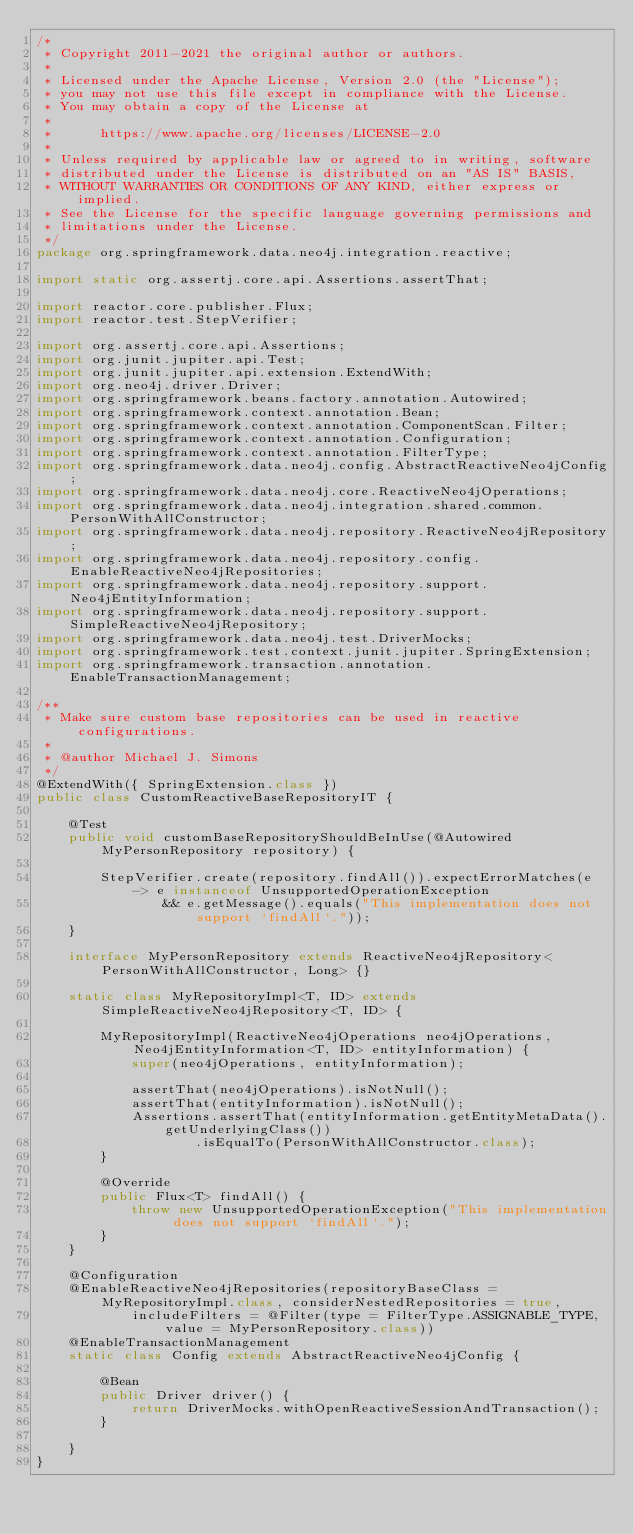Convert code to text. <code><loc_0><loc_0><loc_500><loc_500><_Java_>/*
 * Copyright 2011-2021 the original author or authors.
 *
 * Licensed under the Apache License, Version 2.0 (the "License");
 * you may not use this file except in compliance with the License.
 * You may obtain a copy of the License at
 *
 *      https://www.apache.org/licenses/LICENSE-2.0
 *
 * Unless required by applicable law or agreed to in writing, software
 * distributed under the License is distributed on an "AS IS" BASIS,
 * WITHOUT WARRANTIES OR CONDITIONS OF ANY KIND, either express or implied.
 * See the License for the specific language governing permissions and
 * limitations under the License.
 */
package org.springframework.data.neo4j.integration.reactive;

import static org.assertj.core.api.Assertions.assertThat;

import reactor.core.publisher.Flux;
import reactor.test.StepVerifier;

import org.assertj.core.api.Assertions;
import org.junit.jupiter.api.Test;
import org.junit.jupiter.api.extension.ExtendWith;
import org.neo4j.driver.Driver;
import org.springframework.beans.factory.annotation.Autowired;
import org.springframework.context.annotation.Bean;
import org.springframework.context.annotation.ComponentScan.Filter;
import org.springframework.context.annotation.Configuration;
import org.springframework.context.annotation.FilterType;
import org.springframework.data.neo4j.config.AbstractReactiveNeo4jConfig;
import org.springframework.data.neo4j.core.ReactiveNeo4jOperations;
import org.springframework.data.neo4j.integration.shared.common.PersonWithAllConstructor;
import org.springframework.data.neo4j.repository.ReactiveNeo4jRepository;
import org.springframework.data.neo4j.repository.config.EnableReactiveNeo4jRepositories;
import org.springframework.data.neo4j.repository.support.Neo4jEntityInformation;
import org.springframework.data.neo4j.repository.support.SimpleReactiveNeo4jRepository;
import org.springframework.data.neo4j.test.DriverMocks;
import org.springframework.test.context.junit.jupiter.SpringExtension;
import org.springframework.transaction.annotation.EnableTransactionManagement;

/**
 * Make sure custom base repositories can be used in reactive configurations.
 *
 * @author Michael J. Simons
 */
@ExtendWith({ SpringExtension.class })
public class CustomReactiveBaseRepositoryIT {

	@Test
	public void customBaseRepositoryShouldBeInUse(@Autowired MyPersonRepository repository) {

		StepVerifier.create(repository.findAll()).expectErrorMatches(e -> e instanceof UnsupportedOperationException
				&& e.getMessage().equals("This implementation does not support `findAll`."));
	}

	interface MyPersonRepository extends ReactiveNeo4jRepository<PersonWithAllConstructor, Long> {}

	static class MyRepositoryImpl<T, ID> extends SimpleReactiveNeo4jRepository<T, ID> {

		MyRepositoryImpl(ReactiveNeo4jOperations neo4jOperations, Neo4jEntityInformation<T, ID> entityInformation) {
			super(neo4jOperations, entityInformation);

			assertThat(neo4jOperations).isNotNull();
			assertThat(entityInformation).isNotNull();
			Assertions.assertThat(entityInformation.getEntityMetaData().getUnderlyingClass())
					.isEqualTo(PersonWithAllConstructor.class);
		}

		@Override
		public Flux<T> findAll() {
			throw new UnsupportedOperationException("This implementation does not support `findAll`.");
		}
	}

	@Configuration
	@EnableReactiveNeo4jRepositories(repositoryBaseClass = MyRepositoryImpl.class, considerNestedRepositories = true,
			includeFilters = @Filter(type = FilterType.ASSIGNABLE_TYPE, value = MyPersonRepository.class))
	@EnableTransactionManagement
	static class Config extends AbstractReactiveNeo4jConfig {

		@Bean
		public Driver driver() {
			return DriverMocks.withOpenReactiveSessionAndTransaction();
		}

	}
}
</code> 